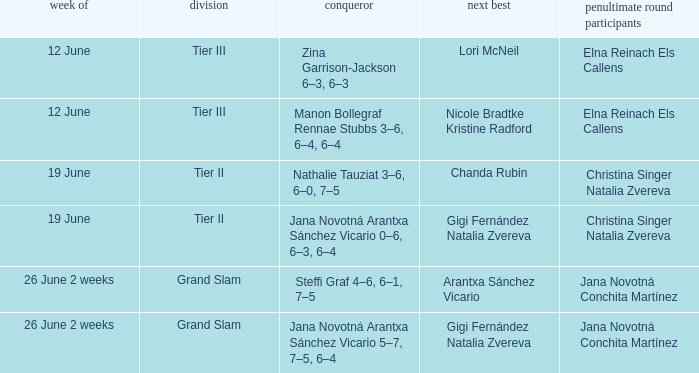When the second-place finisher is mentioned as gigi fernández natalia zvereva and the week is 26 june for 2 weeks, who are the semi-finalists? Jana Novotná Conchita Martínez. 